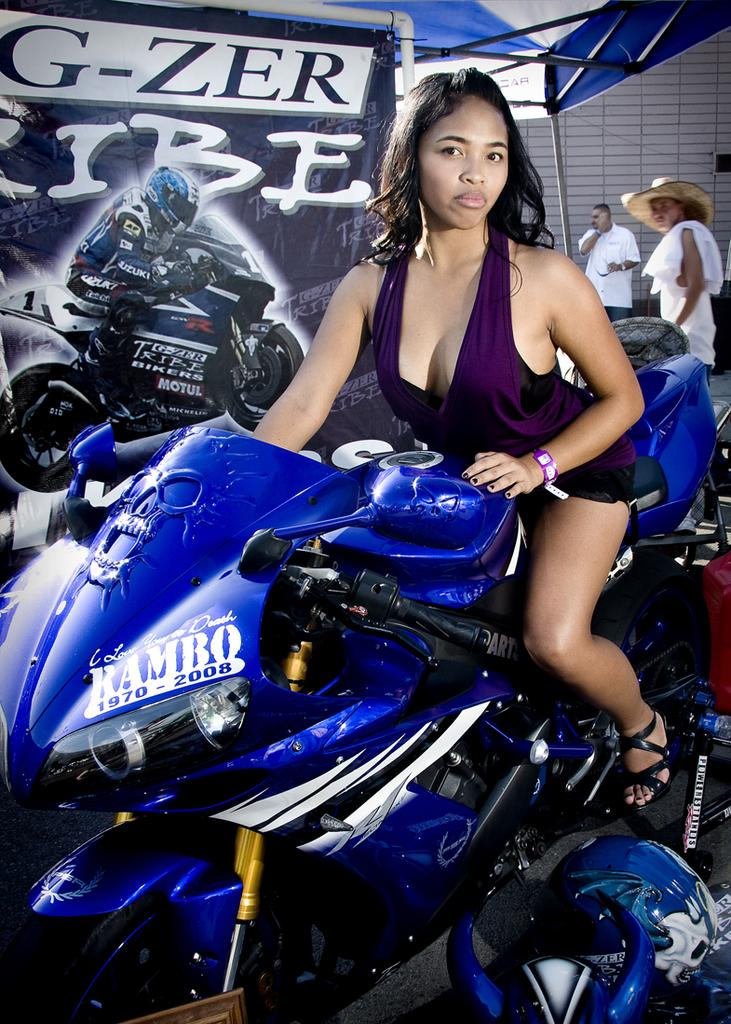Who is present in the image? There is a woman in the image. What is the woman wearing? The woman is wearing a purple dress. What is the woman sitting on? The woman is sitting on a blue color bike. What can be seen in the background of the image? There is a banner and a tent in the background of the image. What type of appliance is the woman using in the image? There is no appliance present in the image. How many bulbs are visible in the image? There are no bulbs visible in the image. 